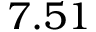Convert formula to latex. <formula><loc_0><loc_0><loc_500><loc_500>7 . 5 1</formula> 